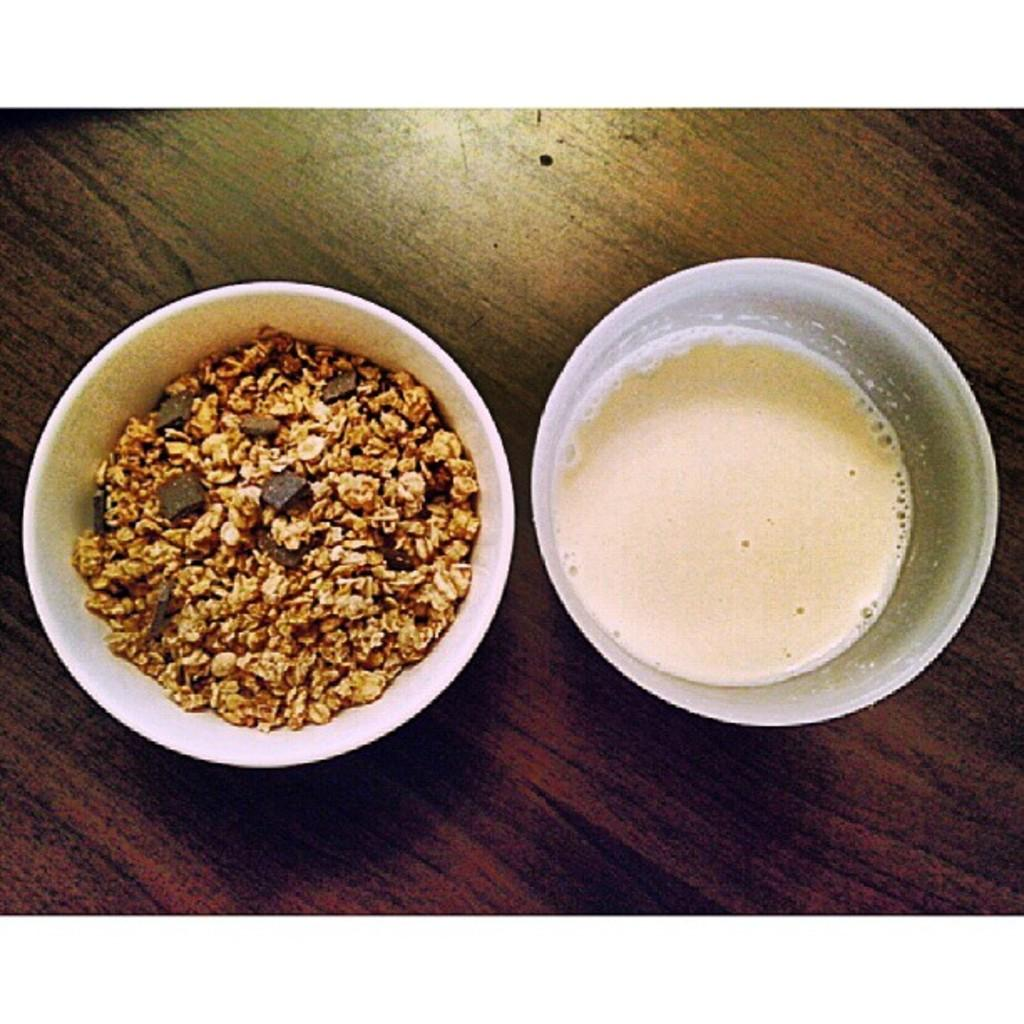What types of food items can be seen in the image? There are two different food items in the image. What color is the bowl that contains the food items? The bowl is white in color. Where is the bowl placed in the image? The bowl is kept on a wooden floor. What type of wool is used to make the plate in the image? There is no plate present in the image, and therefore no wool is used to make it. 